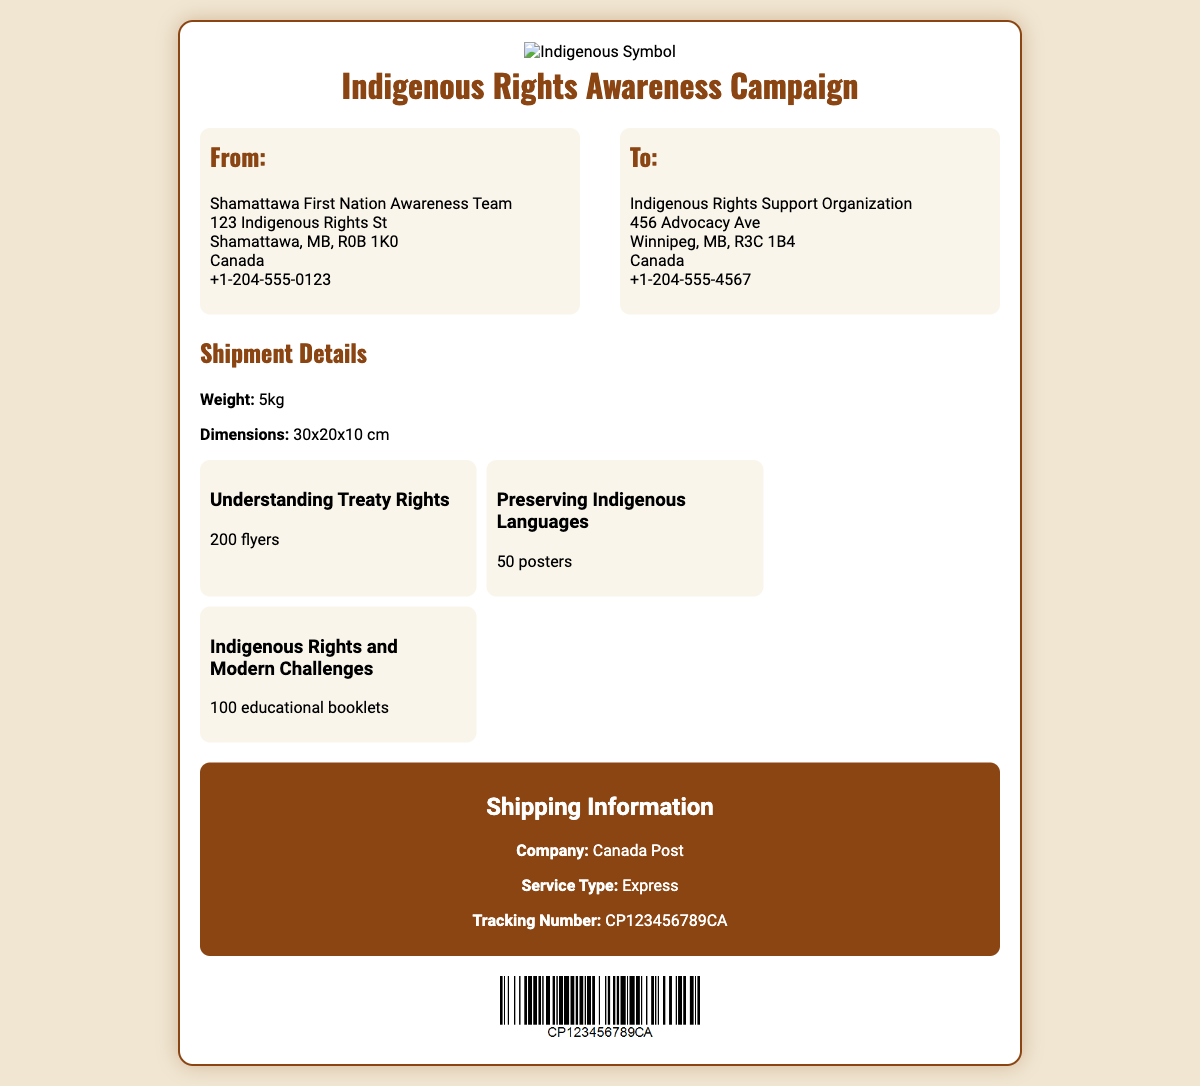what is the weight of the shipment? The weight of the shipment is explicitly stated in the document as 5kg.
Answer: 5kg what is the address of the sender? The sender's address is provided in the document, which includes Shamattawa First Nation Awareness Team, 123 Indigenous Rights St, Shamattawa, MB, R0B 1K0, Canada.
Answer: Shamattawa First Nation Awareness Team, 123 Indigenous Rights St, Shamattawa, MB, R0B 1K0, Canada how many educational booklets are included? The document indicates the number of educational booklets included in the shipment, which is 100.
Answer: 100 who is the shipping company? The shipping company name is mentioned, which is Canada Post.
Answer: Canada Post what is the tracking number for the shipment? The tracking number for this shipment is specified in the document as CP123456789CA.
Answer: CP123456789CA how many flyers are being shipped? The document states the number of flyers being shipped as 200.
Answer: 200 what is the service type for shipping? The service type for shipping is included in the document, identified as Express.
Answer: Express what is the address of the recipient? The recipient's address is provided in the document, which is Indigenous Rights Support Organization, 456 Advocacy Ave, Winnipeg, MB, R3C 1B4, Canada.
Answer: Indigenous Rights Support Organization, 456 Advocacy Ave, Winnipeg, MB, R3C 1B4, Canada what are the dimensions of the shipment? The document provides the dimensions of the shipment, specifically stated as 30x20x10 cm.
Answer: 30x20x10 cm 